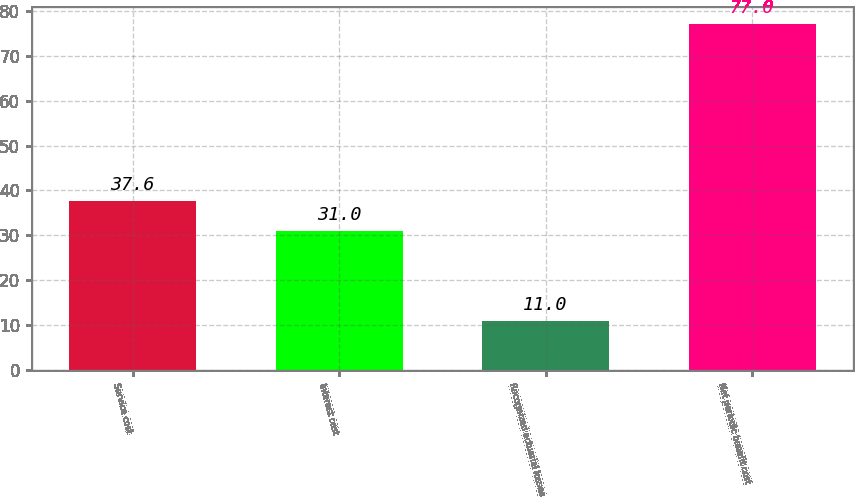Convert chart to OTSL. <chart><loc_0><loc_0><loc_500><loc_500><bar_chart><fcel>Service cost<fcel>Interest cost<fcel>Recognized actuarial losses<fcel>Net periodic benefit cost<nl><fcel>37.6<fcel>31<fcel>11<fcel>77<nl></chart> 